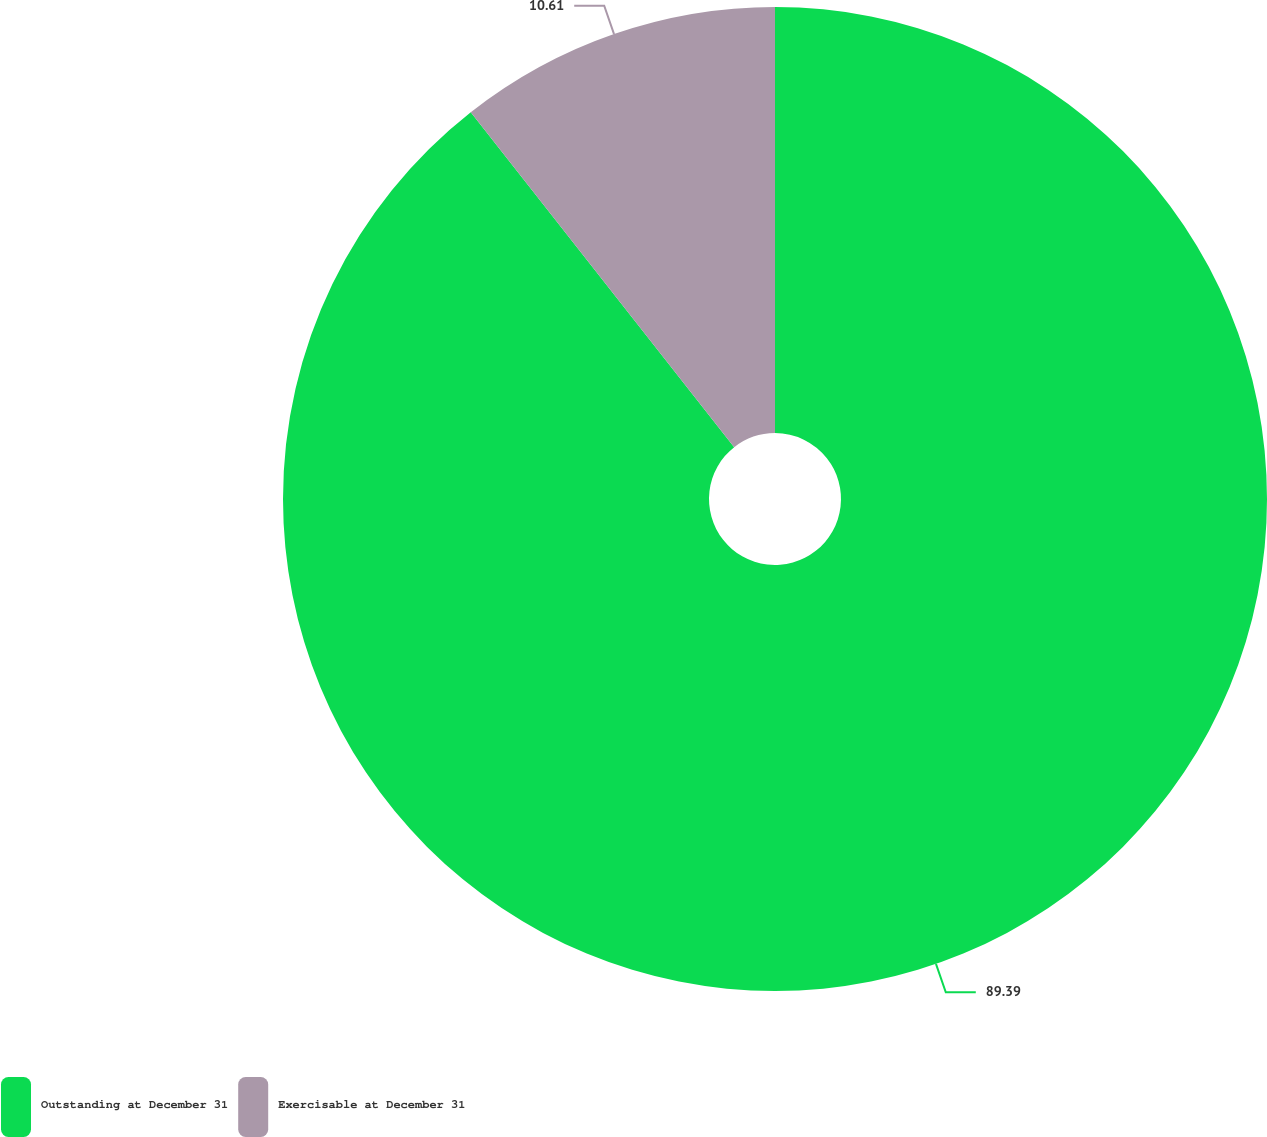Convert chart to OTSL. <chart><loc_0><loc_0><loc_500><loc_500><pie_chart><fcel>Outstanding at December 31<fcel>Exercisable at December 31<nl><fcel>89.39%<fcel>10.61%<nl></chart> 